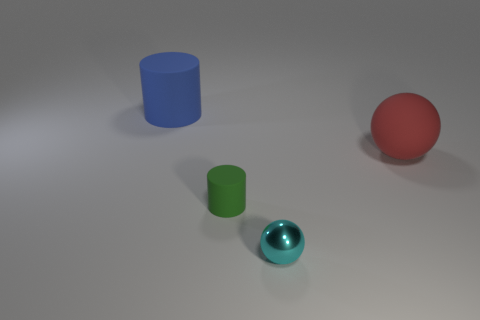Add 4 tiny cyan metal balls. How many objects exist? 8 Subtract all gray blocks. How many purple spheres are left? 0 Add 3 matte cylinders. How many matte cylinders exist? 5 Subtract 1 blue cylinders. How many objects are left? 3 Subtract 1 balls. How many balls are left? 1 Subtract all blue balls. Subtract all cyan blocks. How many balls are left? 2 Subtract all tiny spheres. Subtract all large matte objects. How many objects are left? 1 Add 2 blue cylinders. How many blue cylinders are left? 3 